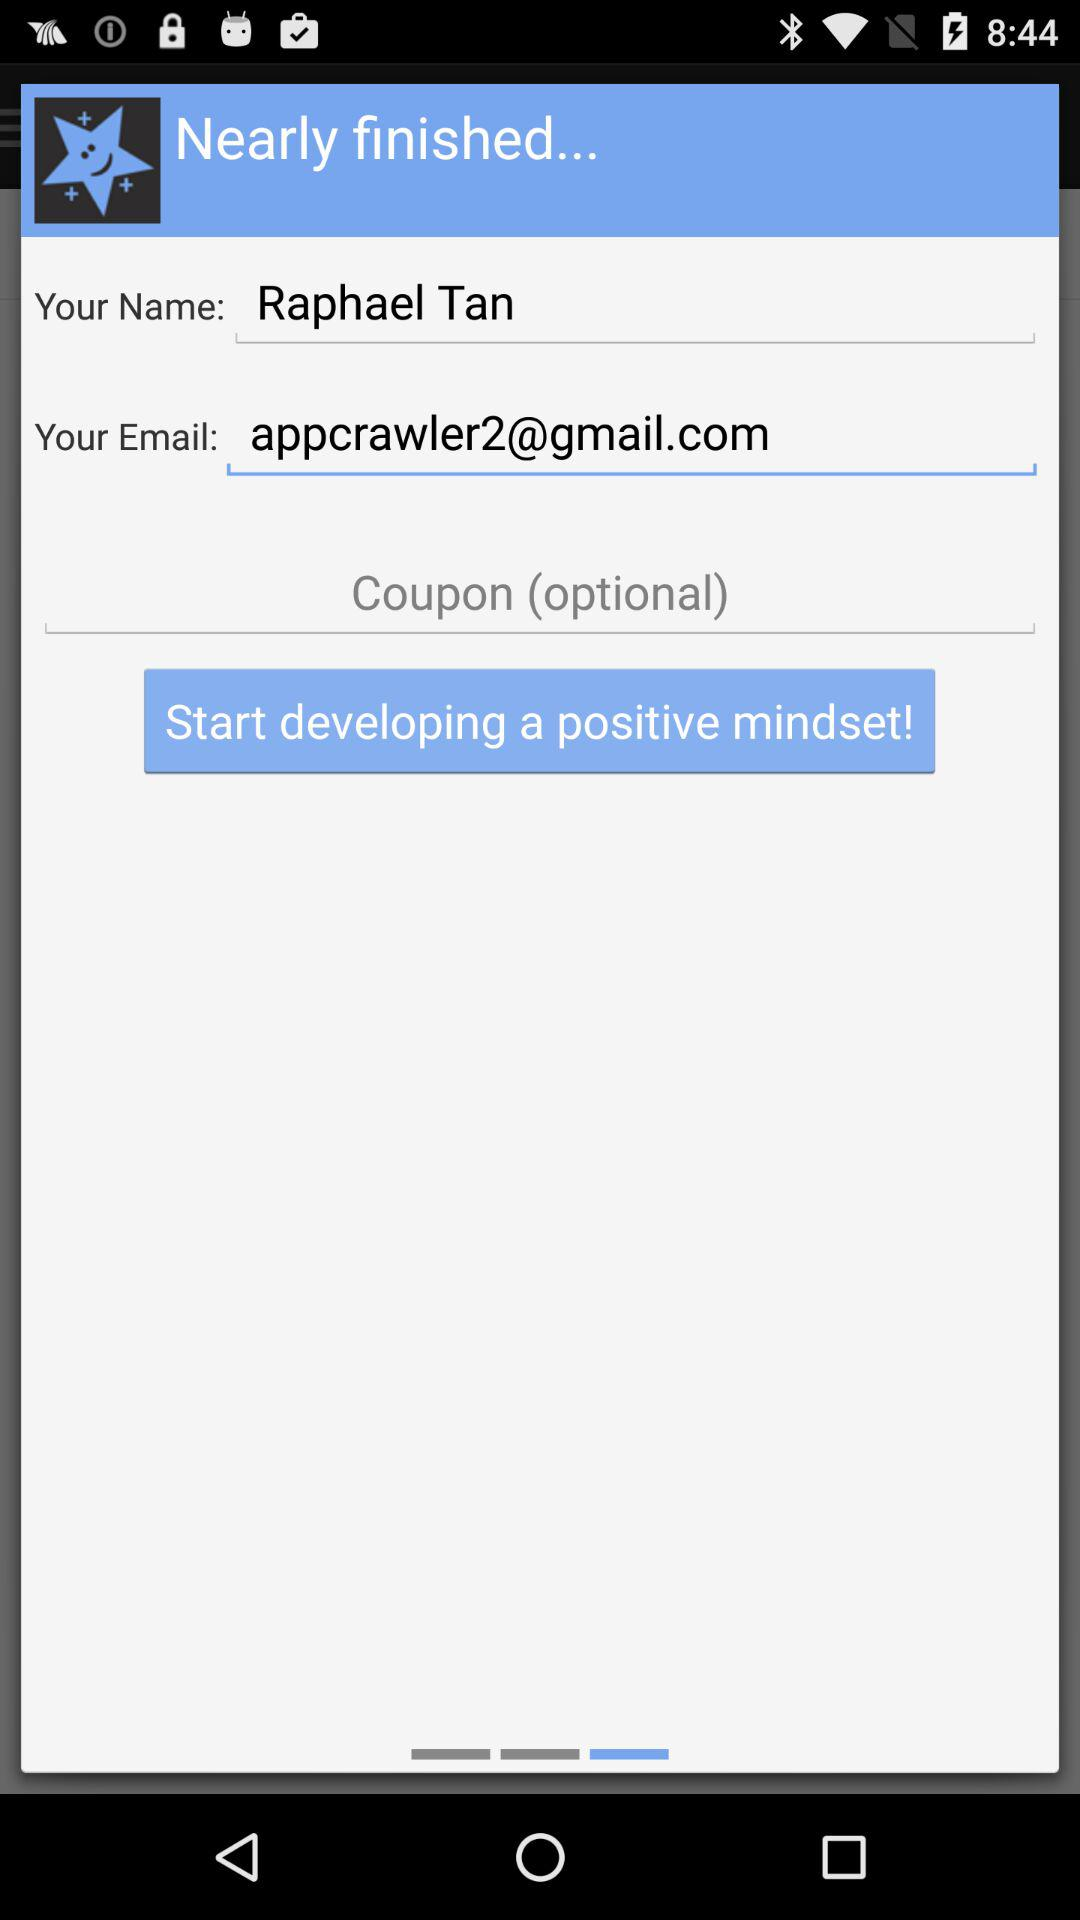What is the name of the user? The name of the user is Raphael Tan. 